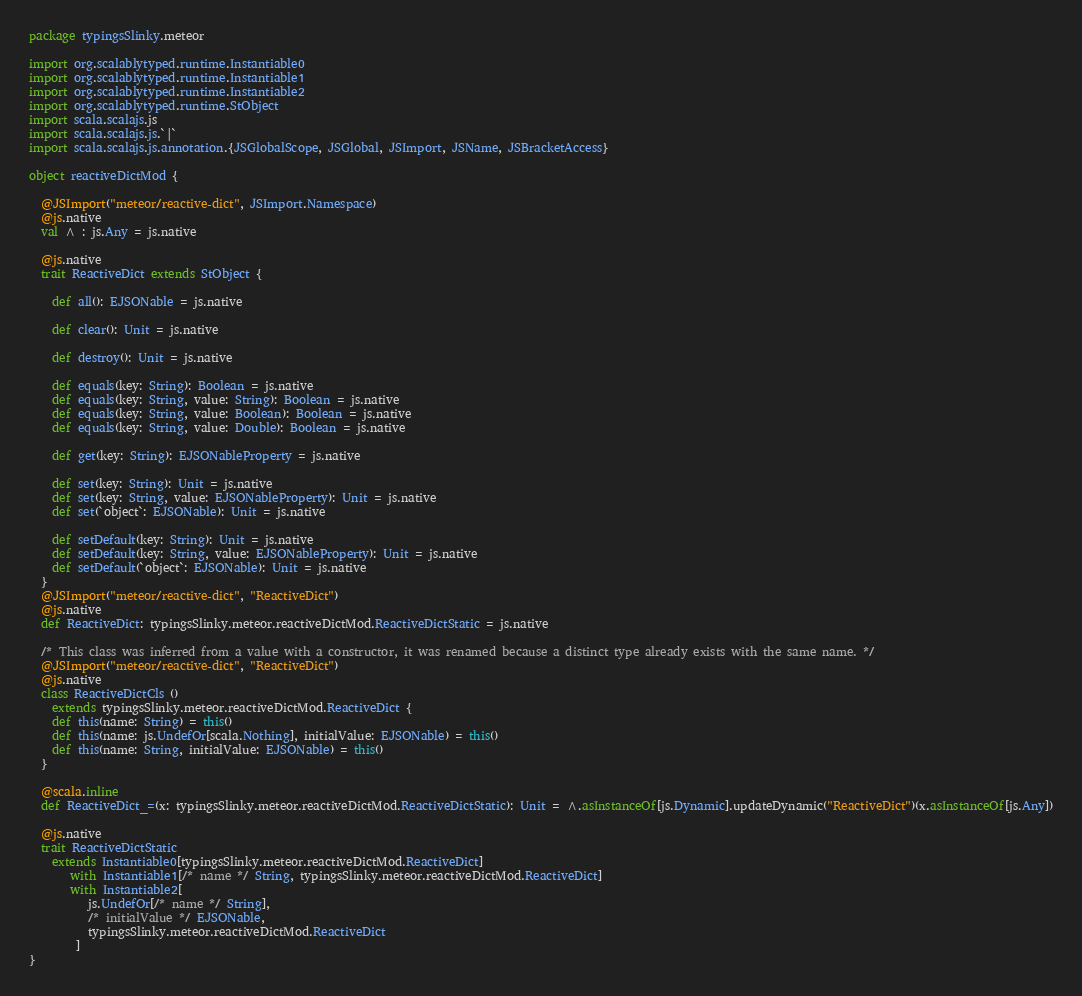Convert code to text. <code><loc_0><loc_0><loc_500><loc_500><_Scala_>package typingsSlinky.meteor

import org.scalablytyped.runtime.Instantiable0
import org.scalablytyped.runtime.Instantiable1
import org.scalablytyped.runtime.Instantiable2
import org.scalablytyped.runtime.StObject
import scala.scalajs.js
import scala.scalajs.js.`|`
import scala.scalajs.js.annotation.{JSGlobalScope, JSGlobal, JSImport, JSName, JSBracketAccess}

object reactiveDictMod {
  
  @JSImport("meteor/reactive-dict", JSImport.Namespace)
  @js.native
  val ^ : js.Any = js.native
  
  @js.native
  trait ReactiveDict extends StObject {
    
    def all(): EJSONable = js.native
    
    def clear(): Unit = js.native
    
    def destroy(): Unit = js.native
    
    def equals(key: String): Boolean = js.native
    def equals(key: String, value: String): Boolean = js.native
    def equals(key: String, value: Boolean): Boolean = js.native
    def equals(key: String, value: Double): Boolean = js.native
    
    def get(key: String): EJSONableProperty = js.native
    
    def set(key: String): Unit = js.native
    def set(key: String, value: EJSONableProperty): Unit = js.native
    def set(`object`: EJSONable): Unit = js.native
    
    def setDefault(key: String): Unit = js.native
    def setDefault(key: String, value: EJSONableProperty): Unit = js.native
    def setDefault(`object`: EJSONable): Unit = js.native
  }
  @JSImport("meteor/reactive-dict", "ReactiveDict")
  @js.native
  def ReactiveDict: typingsSlinky.meteor.reactiveDictMod.ReactiveDictStatic = js.native
  
  /* This class was inferred from a value with a constructor, it was renamed because a distinct type already exists with the same name. */
  @JSImport("meteor/reactive-dict", "ReactiveDict")
  @js.native
  class ReactiveDictCls ()
    extends typingsSlinky.meteor.reactiveDictMod.ReactiveDict {
    def this(name: String) = this()
    def this(name: js.UndefOr[scala.Nothing], initialValue: EJSONable) = this()
    def this(name: String, initialValue: EJSONable) = this()
  }
  
  @scala.inline
  def ReactiveDict_=(x: typingsSlinky.meteor.reactiveDictMod.ReactiveDictStatic): Unit = ^.asInstanceOf[js.Dynamic].updateDynamic("ReactiveDict")(x.asInstanceOf[js.Any])
  
  @js.native
  trait ReactiveDictStatic
    extends Instantiable0[typingsSlinky.meteor.reactiveDictMod.ReactiveDict]
       with Instantiable1[/* name */ String, typingsSlinky.meteor.reactiveDictMod.ReactiveDict]
       with Instantiable2[
          js.UndefOr[/* name */ String], 
          /* initialValue */ EJSONable, 
          typingsSlinky.meteor.reactiveDictMod.ReactiveDict
        ]
}
</code> 